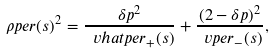Convert formula to latex. <formula><loc_0><loc_0><loc_500><loc_500>\rho p e r ( s ) ^ { 2 } = \frac { \delta p ^ { 2 } } { \ v h a t p e r _ { + } ( s ) } + \frac { ( 2 - \delta p ) ^ { 2 } } { \ v p e r _ { - } ( s ) } ,</formula> 